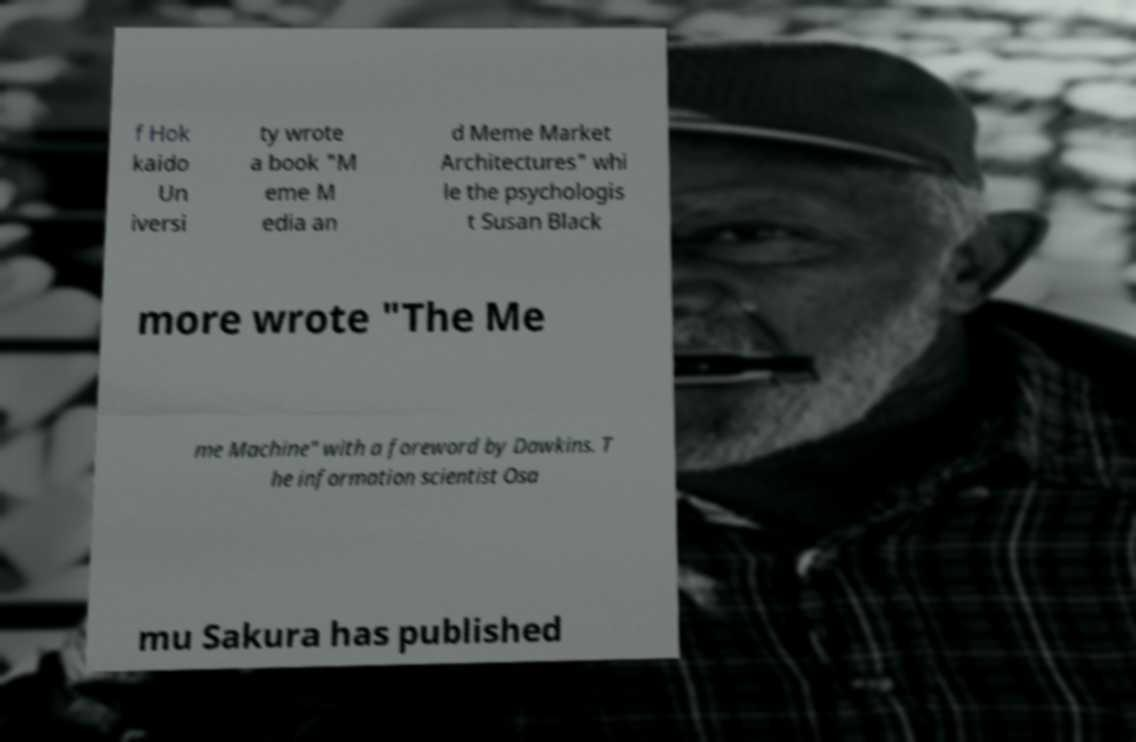Could you extract and type out the text from this image? f Hok kaido Un iversi ty wrote a book "M eme M edia an d Meme Market Architectures" whi le the psychologis t Susan Black more wrote "The Me me Machine" with a foreword by Dawkins. T he information scientist Osa mu Sakura has published 